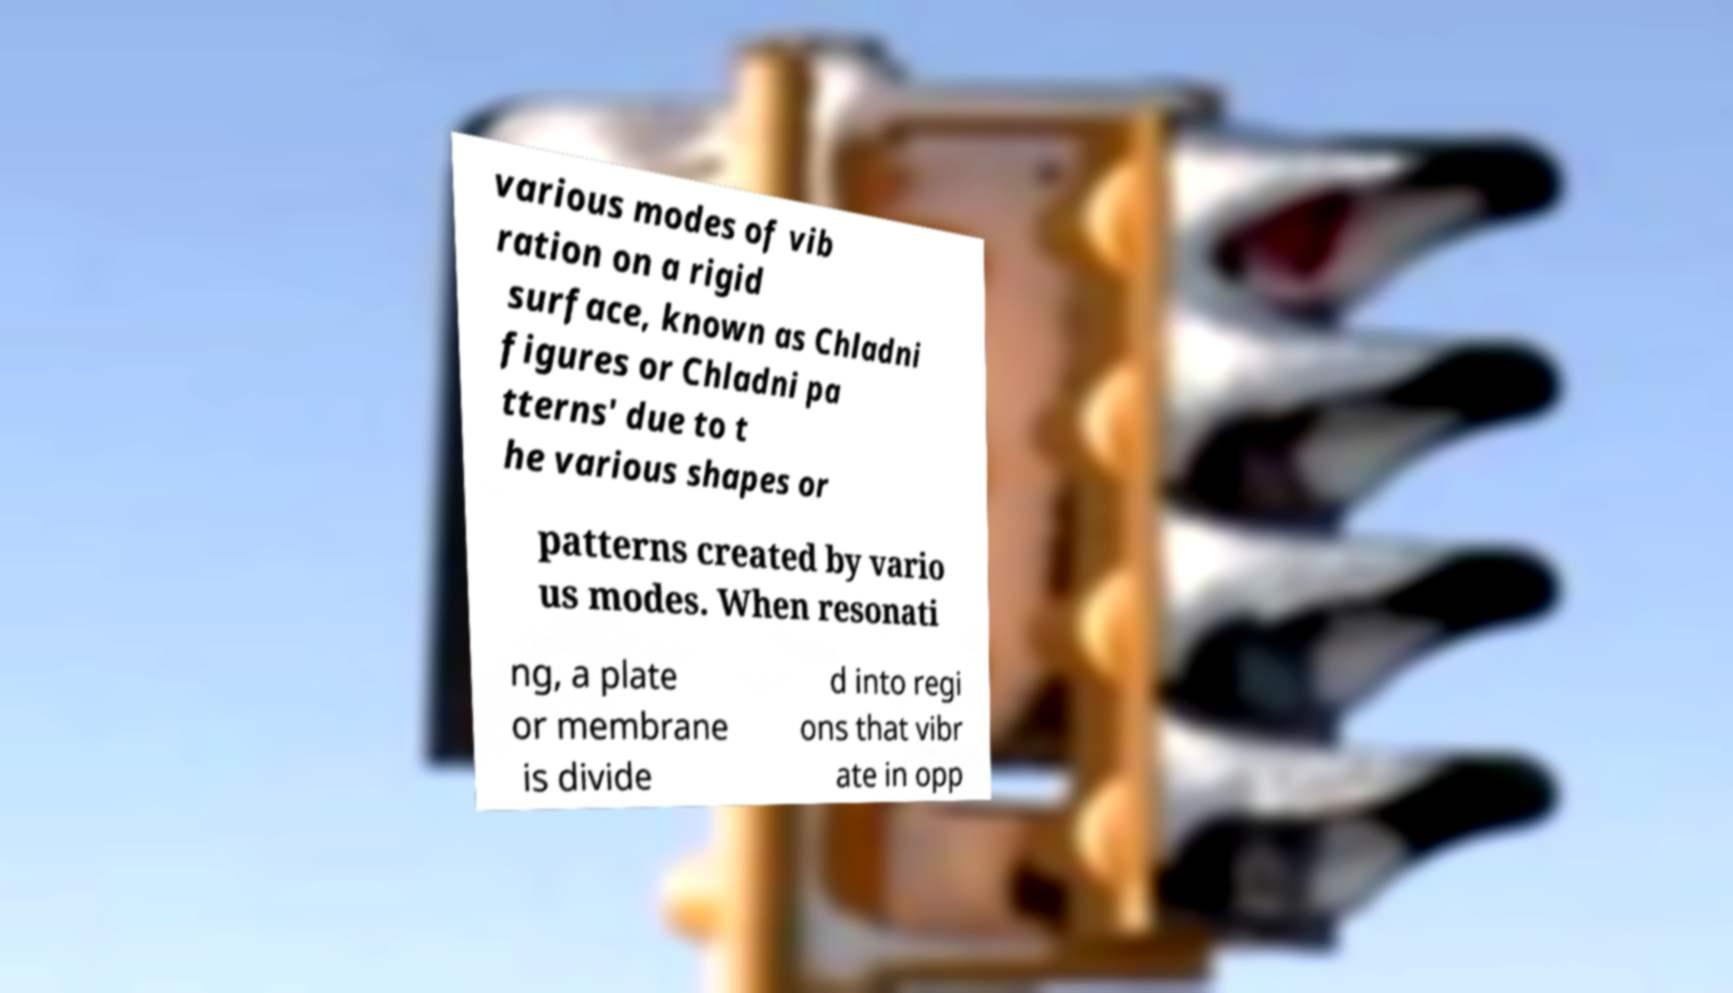There's text embedded in this image that I need extracted. Can you transcribe it verbatim? various modes of vib ration on a rigid surface, known as Chladni figures or Chladni pa tterns' due to t he various shapes or patterns created by vario us modes. When resonati ng, a plate or membrane is divide d into regi ons that vibr ate in opp 